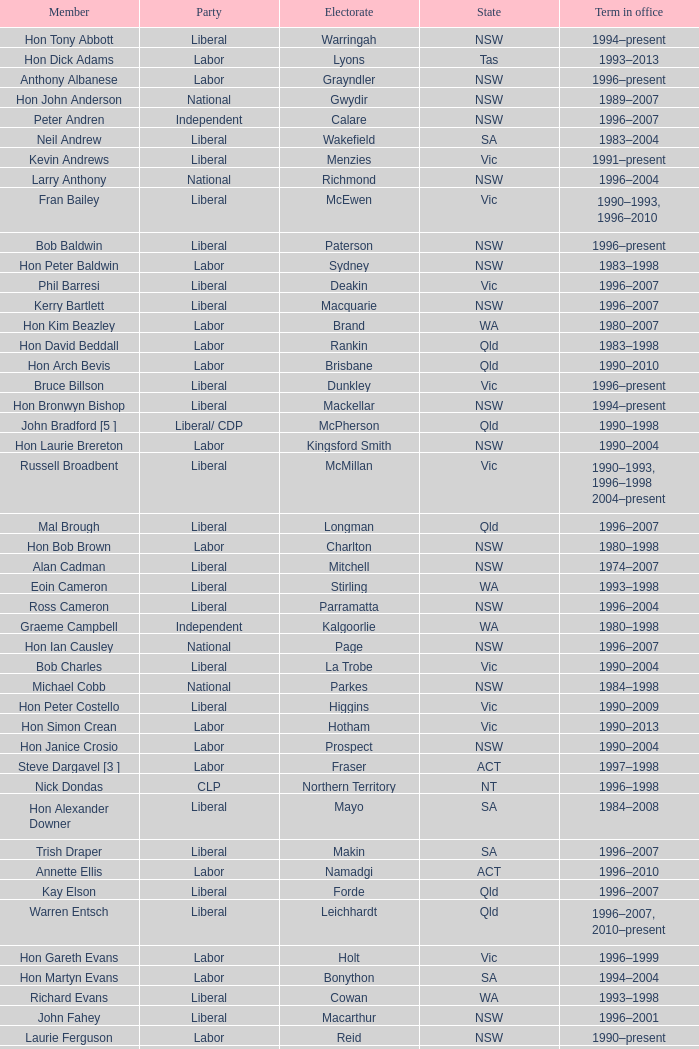In what status was the voter group fowler? NSW. 